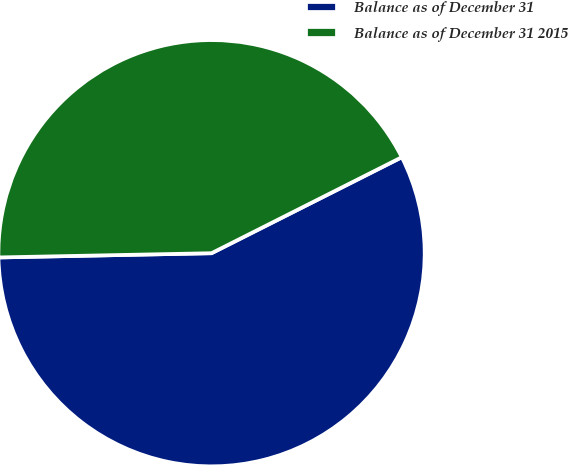Convert chart. <chart><loc_0><loc_0><loc_500><loc_500><pie_chart><fcel>Balance as of December 31<fcel>Balance as of December 31 2015<nl><fcel>57.12%<fcel>42.88%<nl></chart> 